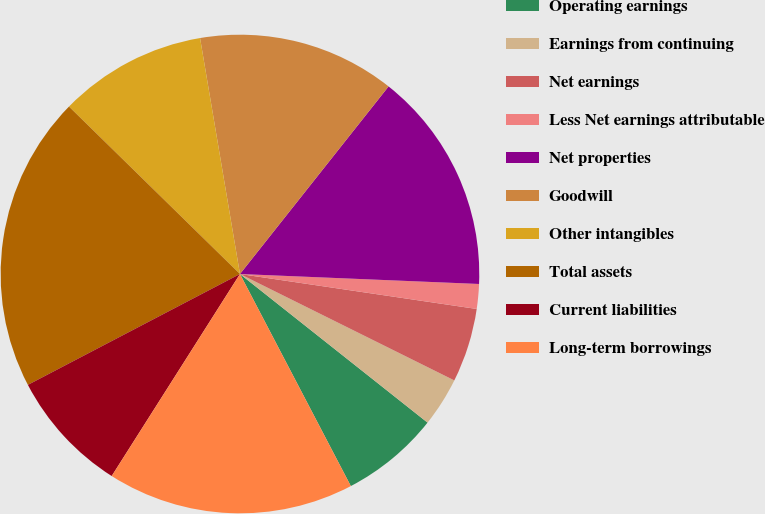Convert chart. <chart><loc_0><loc_0><loc_500><loc_500><pie_chart><fcel>Operating earnings<fcel>Earnings from continuing<fcel>Net earnings<fcel>Less Net earnings attributable<fcel>Net properties<fcel>Goodwill<fcel>Other intangibles<fcel>Total assets<fcel>Current liabilities<fcel>Long-term borrowings<nl><fcel>6.67%<fcel>3.33%<fcel>5.0%<fcel>1.67%<fcel>15.0%<fcel>13.33%<fcel>10.0%<fcel>20.0%<fcel>8.33%<fcel>16.67%<nl></chart> 